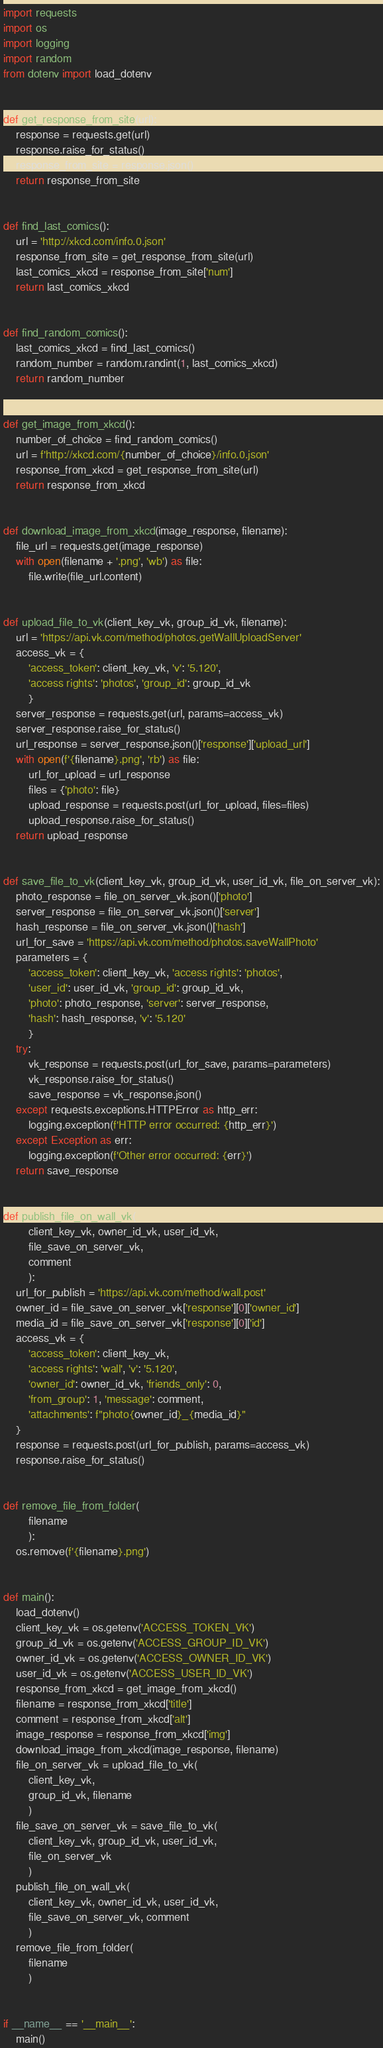<code> <loc_0><loc_0><loc_500><loc_500><_Python_>import requests
import os
import logging
import random
from dotenv import load_dotenv


def get_response_from_site(url):
    response = requests.get(url)
    response.raise_for_status()
    response_from_site = response.json()
    return response_from_site


def find_last_comics():
    url = 'http://xkcd.com/info.0.json'
    response_from_site = get_response_from_site(url)
    last_comics_xkcd = response_from_site['num']
    return last_comics_xkcd


def find_random_comics():
    last_comics_xkcd = find_last_comics()
    random_number = random.randint(1, last_comics_xkcd)
    return random_number


def get_image_from_xkcd():
    number_of_choice = find_random_comics()
    url = f'http://xkcd.com/{number_of_choice}/info.0.json'
    response_from_xkcd = get_response_from_site(url)
    return response_from_xkcd


def download_image_from_xkcd(image_response, filename):
    file_url = requests.get(image_response)
    with open(filename + '.png', 'wb') as file:
        file.write(file_url.content)


def upload_file_to_vk(client_key_vk, group_id_vk, filename):
    url = 'https://api.vk.com/method/photos.getWallUploadServer'
    access_vk = {
        'access_token': client_key_vk, 'v': '5.120',
        'access rights': 'photos', 'group_id': group_id_vk
        }
    server_response = requests.get(url, params=access_vk)
    server_response.raise_for_status()
    url_response = server_response.json()['response']['upload_url']
    with open(f'{filename}.png', 'rb') as file:
        url_for_upload = url_response
        files = {'photo': file}
        upload_response = requests.post(url_for_upload, files=files)
        upload_response.raise_for_status()
    return upload_response


def save_file_to_vk(client_key_vk, group_id_vk, user_id_vk, file_on_server_vk):
    photo_response = file_on_server_vk.json()['photo']
    server_response = file_on_server_vk.json()['server']
    hash_response = file_on_server_vk.json()['hash']
    url_for_save = 'https://api.vk.com/method/photos.saveWallPhoto'
    parameters = {
        'access_token': client_key_vk, 'access rights': 'photos',
        'user_id': user_id_vk, 'group_id': group_id_vk,
        'photo': photo_response, 'server': server_response,
        'hash': hash_response, 'v': '5.120'
        }
    try:
        vk_response = requests.post(url_for_save, params=parameters)
        vk_response.raise_for_status()
        save_response = vk_response.json()
    except requests.exceptions.HTTPError as http_err:
        logging.exception(f'HTTP error occurred: {http_err}')
    except Exception as err:
        logging.exception(f'Other error occurred: {err}')
    return save_response


def publish_file_on_wall_vk(
        client_key_vk, owner_id_vk, user_id_vk,
        file_save_on_server_vk,
        comment
        ):
    url_for_publish = 'https://api.vk.com/method/wall.post'
    owner_id = file_save_on_server_vk['response'][0]['owner_id']
    media_id = file_save_on_server_vk['response'][0]['id']
    access_vk = {
        'access_token': client_key_vk,
        'access rights': 'wall', 'v': '5.120',
        'owner_id': owner_id_vk, 'friends_only': 0,
        'from_group': 1, 'message': comment,
        'attachments': f"photo{owner_id}_{media_id}"
    }
    response = requests.post(url_for_publish, params=access_vk)
    response.raise_for_status()


def remove_file_from_folder(
        filename
        ):
    os.remove(f'{filename}.png')


def main():
    load_dotenv()
    client_key_vk = os.getenv('ACCESS_TOKEN_VK')
    group_id_vk = os.getenv('ACCESS_GROUP_ID_VK')
    owner_id_vk = os.getenv('ACCESS_OWNER_ID_VK')
    user_id_vk = os.getenv('ACCESS_USER_ID_VK')
    response_from_xkcd = get_image_from_xkcd()
    filename = response_from_xkcd['title']
    comment = response_from_xkcd['alt']
    image_response = response_from_xkcd['img']
    download_image_from_xkcd(image_response, filename)
    file_on_server_vk = upload_file_to_vk(
        client_key_vk,
        group_id_vk, filename
        )
    file_save_on_server_vk = save_file_to_vk(
        client_key_vk, group_id_vk, user_id_vk,
        file_on_server_vk
        )
    publish_file_on_wall_vk(
        client_key_vk, owner_id_vk, user_id_vk,
        file_save_on_server_vk, comment
        )
    remove_file_from_folder(
        filename
        )


if __name__ == '__main__':
    main()
</code> 